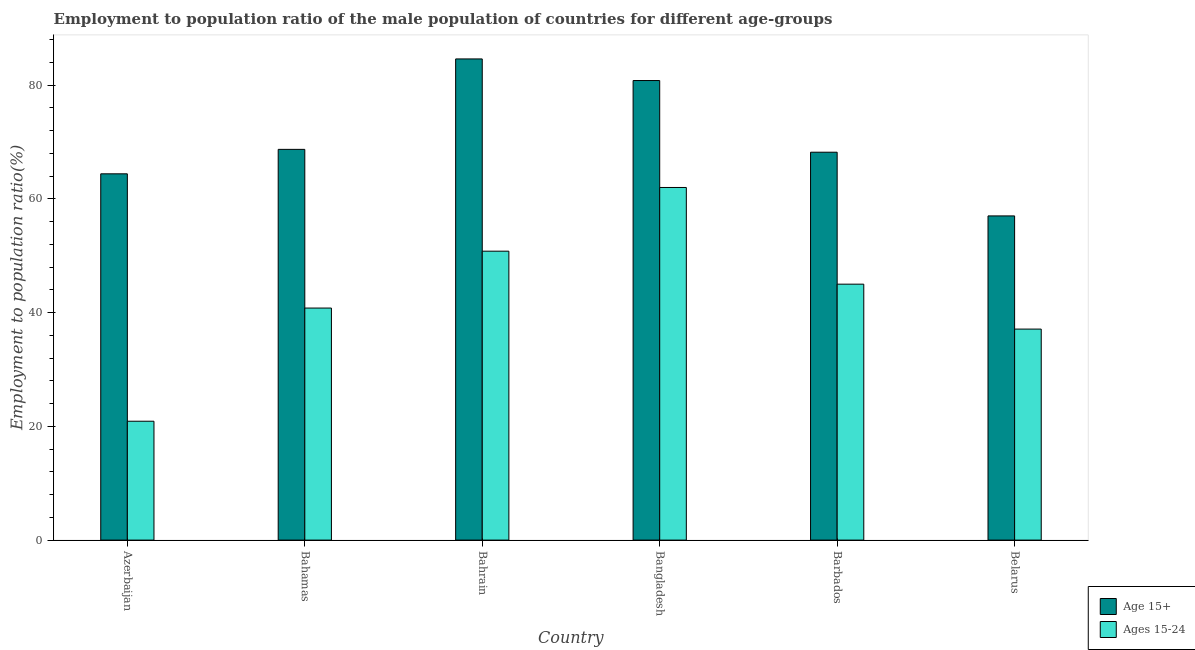What is the label of the 3rd group of bars from the left?
Make the answer very short. Bahrain. What is the employment to population ratio(age 15-24) in Bangladesh?
Give a very brief answer. 62. Across all countries, what is the maximum employment to population ratio(age 15-24)?
Give a very brief answer. 62. Across all countries, what is the minimum employment to population ratio(age 15-24)?
Offer a very short reply. 20.9. In which country was the employment to population ratio(age 15+) maximum?
Your answer should be very brief. Bahrain. In which country was the employment to population ratio(age 15+) minimum?
Provide a succinct answer. Belarus. What is the total employment to population ratio(age 15-24) in the graph?
Your answer should be very brief. 256.6. What is the difference between the employment to population ratio(age 15+) in Bahamas and the employment to population ratio(age 15-24) in Azerbaijan?
Make the answer very short. 47.8. What is the average employment to population ratio(age 15+) per country?
Your answer should be compact. 70.62. What is the difference between the employment to population ratio(age 15-24) and employment to population ratio(age 15+) in Bangladesh?
Offer a terse response. -18.8. In how many countries, is the employment to population ratio(age 15-24) greater than 4 %?
Make the answer very short. 6. What is the ratio of the employment to population ratio(age 15-24) in Bahamas to that in Belarus?
Offer a terse response. 1.1. Is the difference between the employment to population ratio(age 15+) in Bangladesh and Barbados greater than the difference between the employment to population ratio(age 15-24) in Bangladesh and Barbados?
Offer a terse response. No. What is the difference between the highest and the second highest employment to population ratio(age 15-24)?
Give a very brief answer. 11.2. What is the difference between the highest and the lowest employment to population ratio(age 15+)?
Ensure brevity in your answer.  27.6. What does the 1st bar from the left in Bahamas represents?
Ensure brevity in your answer.  Age 15+. What does the 1st bar from the right in Bahrain represents?
Keep it short and to the point. Ages 15-24. How many bars are there?
Make the answer very short. 12. Are all the bars in the graph horizontal?
Your answer should be compact. No. Are the values on the major ticks of Y-axis written in scientific E-notation?
Give a very brief answer. No. Does the graph contain any zero values?
Your response must be concise. No. Does the graph contain grids?
Your response must be concise. No. How many legend labels are there?
Your answer should be very brief. 2. What is the title of the graph?
Your answer should be compact. Employment to population ratio of the male population of countries for different age-groups. Does "Girls" appear as one of the legend labels in the graph?
Give a very brief answer. No. What is the label or title of the X-axis?
Offer a very short reply. Country. What is the Employment to population ratio(%) in Age 15+ in Azerbaijan?
Offer a very short reply. 64.4. What is the Employment to population ratio(%) in Ages 15-24 in Azerbaijan?
Your response must be concise. 20.9. What is the Employment to population ratio(%) in Age 15+ in Bahamas?
Offer a very short reply. 68.7. What is the Employment to population ratio(%) of Ages 15-24 in Bahamas?
Keep it short and to the point. 40.8. What is the Employment to population ratio(%) of Age 15+ in Bahrain?
Offer a very short reply. 84.6. What is the Employment to population ratio(%) in Ages 15-24 in Bahrain?
Keep it short and to the point. 50.8. What is the Employment to population ratio(%) in Age 15+ in Bangladesh?
Provide a short and direct response. 80.8. What is the Employment to population ratio(%) of Ages 15-24 in Bangladesh?
Provide a short and direct response. 62. What is the Employment to population ratio(%) in Age 15+ in Barbados?
Your answer should be very brief. 68.2. What is the Employment to population ratio(%) in Ages 15-24 in Barbados?
Ensure brevity in your answer.  45. What is the Employment to population ratio(%) in Ages 15-24 in Belarus?
Keep it short and to the point. 37.1. Across all countries, what is the maximum Employment to population ratio(%) in Age 15+?
Your response must be concise. 84.6. Across all countries, what is the maximum Employment to population ratio(%) in Ages 15-24?
Your response must be concise. 62. Across all countries, what is the minimum Employment to population ratio(%) in Ages 15-24?
Your answer should be compact. 20.9. What is the total Employment to population ratio(%) of Age 15+ in the graph?
Make the answer very short. 423.7. What is the total Employment to population ratio(%) of Ages 15-24 in the graph?
Offer a terse response. 256.6. What is the difference between the Employment to population ratio(%) in Ages 15-24 in Azerbaijan and that in Bahamas?
Provide a succinct answer. -19.9. What is the difference between the Employment to population ratio(%) in Age 15+ in Azerbaijan and that in Bahrain?
Provide a short and direct response. -20.2. What is the difference between the Employment to population ratio(%) of Ages 15-24 in Azerbaijan and that in Bahrain?
Make the answer very short. -29.9. What is the difference between the Employment to population ratio(%) in Age 15+ in Azerbaijan and that in Bangladesh?
Your answer should be very brief. -16.4. What is the difference between the Employment to population ratio(%) in Ages 15-24 in Azerbaijan and that in Bangladesh?
Your response must be concise. -41.1. What is the difference between the Employment to population ratio(%) of Age 15+ in Azerbaijan and that in Barbados?
Keep it short and to the point. -3.8. What is the difference between the Employment to population ratio(%) of Ages 15-24 in Azerbaijan and that in Barbados?
Provide a succinct answer. -24.1. What is the difference between the Employment to population ratio(%) in Age 15+ in Azerbaijan and that in Belarus?
Provide a succinct answer. 7.4. What is the difference between the Employment to population ratio(%) of Ages 15-24 in Azerbaijan and that in Belarus?
Your answer should be very brief. -16.2. What is the difference between the Employment to population ratio(%) of Age 15+ in Bahamas and that in Bahrain?
Offer a terse response. -15.9. What is the difference between the Employment to population ratio(%) of Age 15+ in Bahamas and that in Bangladesh?
Your answer should be very brief. -12.1. What is the difference between the Employment to population ratio(%) of Ages 15-24 in Bahamas and that in Bangladesh?
Your response must be concise. -21.2. What is the difference between the Employment to population ratio(%) of Age 15+ in Bahamas and that in Barbados?
Keep it short and to the point. 0.5. What is the difference between the Employment to population ratio(%) of Age 15+ in Bahamas and that in Belarus?
Offer a very short reply. 11.7. What is the difference between the Employment to population ratio(%) of Ages 15-24 in Bahamas and that in Belarus?
Keep it short and to the point. 3.7. What is the difference between the Employment to population ratio(%) in Ages 15-24 in Bahrain and that in Barbados?
Provide a succinct answer. 5.8. What is the difference between the Employment to population ratio(%) of Age 15+ in Bahrain and that in Belarus?
Give a very brief answer. 27.6. What is the difference between the Employment to population ratio(%) in Age 15+ in Bangladesh and that in Barbados?
Offer a very short reply. 12.6. What is the difference between the Employment to population ratio(%) in Age 15+ in Bangladesh and that in Belarus?
Your answer should be compact. 23.8. What is the difference between the Employment to population ratio(%) of Ages 15-24 in Bangladesh and that in Belarus?
Your response must be concise. 24.9. What is the difference between the Employment to population ratio(%) in Age 15+ in Barbados and that in Belarus?
Your answer should be compact. 11.2. What is the difference between the Employment to population ratio(%) of Age 15+ in Azerbaijan and the Employment to population ratio(%) of Ages 15-24 in Bahamas?
Ensure brevity in your answer.  23.6. What is the difference between the Employment to population ratio(%) in Age 15+ in Azerbaijan and the Employment to population ratio(%) in Ages 15-24 in Bangladesh?
Provide a succinct answer. 2.4. What is the difference between the Employment to population ratio(%) in Age 15+ in Azerbaijan and the Employment to population ratio(%) in Ages 15-24 in Barbados?
Your response must be concise. 19.4. What is the difference between the Employment to population ratio(%) of Age 15+ in Azerbaijan and the Employment to population ratio(%) of Ages 15-24 in Belarus?
Give a very brief answer. 27.3. What is the difference between the Employment to population ratio(%) of Age 15+ in Bahamas and the Employment to population ratio(%) of Ages 15-24 in Bangladesh?
Offer a very short reply. 6.7. What is the difference between the Employment to population ratio(%) in Age 15+ in Bahamas and the Employment to population ratio(%) in Ages 15-24 in Barbados?
Make the answer very short. 23.7. What is the difference between the Employment to population ratio(%) in Age 15+ in Bahamas and the Employment to population ratio(%) in Ages 15-24 in Belarus?
Provide a succinct answer. 31.6. What is the difference between the Employment to population ratio(%) of Age 15+ in Bahrain and the Employment to population ratio(%) of Ages 15-24 in Bangladesh?
Give a very brief answer. 22.6. What is the difference between the Employment to population ratio(%) of Age 15+ in Bahrain and the Employment to population ratio(%) of Ages 15-24 in Barbados?
Your answer should be compact. 39.6. What is the difference between the Employment to population ratio(%) in Age 15+ in Bahrain and the Employment to population ratio(%) in Ages 15-24 in Belarus?
Keep it short and to the point. 47.5. What is the difference between the Employment to population ratio(%) of Age 15+ in Bangladesh and the Employment to population ratio(%) of Ages 15-24 in Barbados?
Keep it short and to the point. 35.8. What is the difference between the Employment to population ratio(%) in Age 15+ in Bangladesh and the Employment to population ratio(%) in Ages 15-24 in Belarus?
Your answer should be compact. 43.7. What is the difference between the Employment to population ratio(%) in Age 15+ in Barbados and the Employment to population ratio(%) in Ages 15-24 in Belarus?
Your answer should be compact. 31.1. What is the average Employment to population ratio(%) of Age 15+ per country?
Offer a very short reply. 70.62. What is the average Employment to population ratio(%) in Ages 15-24 per country?
Your answer should be compact. 42.77. What is the difference between the Employment to population ratio(%) in Age 15+ and Employment to population ratio(%) in Ages 15-24 in Azerbaijan?
Ensure brevity in your answer.  43.5. What is the difference between the Employment to population ratio(%) of Age 15+ and Employment to population ratio(%) of Ages 15-24 in Bahamas?
Keep it short and to the point. 27.9. What is the difference between the Employment to population ratio(%) in Age 15+ and Employment to population ratio(%) in Ages 15-24 in Bahrain?
Offer a very short reply. 33.8. What is the difference between the Employment to population ratio(%) of Age 15+ and Employment to population ratio(%) of Ages 15-24 in Bangladesh?
Provide a short and direct response. 18.8. What is the difference between the Employment to population ratio(%) of Age 15+ and Employment to population ratio(%) of Ages 15-24 in Barbados?
Your answer should be compact. 23.2. What is the ratio of the Employment to population ratio(%) in Age 15+ in Azerbaijan to that in Bahamas?
Offer a very short reply. 0.94. What is the ratio of the Employment to population ratio(%) in Ages 15-24 in Azerbaijan to that in Bahamas?
Your response must be concise. 0.51. What is the ratio of the Employment to population ratio(%) in Age 15+ in Azerbaijan to that in Bahrain?
Your answer should be very brief. 0.76. What is the ratio of the Employment to population ratio(%) in Ages 15-24 in Azerbaijan to that in Bahrain?
Offer a terse response. 0.41. What is the ratio of the Employment to population ratio(%) of Age 15+ in Azerbaijan to that in Bangladesh?
Provide a succinct answer. 0.8. What is the ratio of the Employment to population ratio(%) of Ages 15-24 in Azerbaijan to that in Bangladesh?
Your answer should be very brief. 0.34. What is the ratio of the Employment to population ratio(%) in Age 15+ in Azerbaijan to that in Barbados?
Offer a very short reply. 0.94. What is the ratio of the Employment to population ratio(%) in Ages 15-24 in Azerbaijan to that in Barbados?
Offer a terse response. 0.46. What is the ratio of the Employment to population ratio(%) of Age 15+ in Azerbaijan to that in Belarus?
Keep it short and to the point. 1.13. What is the ratio of the Employment to population ratio(%) in Ages 15-24 in Azerbaijan to that in Belarus?
Offer a very short reply. 0.56. What is the ratio of the Employment to population ratio(%) in Age 15+ in Bahamas to that in Bahrain?
Keep it short and to the point. 0.81. What is the ratio of the Employment to population ratio(%) in Ages 15-24 in Bahamas to that in Bahrain?
Your response must be concise. 0.8. What is the ratio of the Employment to population ratio(%) of Age 15+ in Bahamas to that in Bangladesh?
Your answer should be very brief. 0.85. What is the ratio of the Employment to population ratio(%) in Ages 15-24 in Bahamas to that in Bangladesh?
Keep it short and to the point. 0.66. What is the ratio of the Employment to population ratio(%) of Age 15+ in Bahamas to that in Barbados?
Make the answer very short. 1.01. What is the ratio of the Employment to population ratio(%) of Ages 15-24 in Bahamas to that in Barbados?
Provide a succinct answer. 0.91. What is the ratio of the Employment to population ratio(%) of Age 15+ in Bahamas to that in Belarus?
Your answer should be very brief. 1.21. What is the ratio of the Employment to population ratio(%) in Ages 15-24 in Bahamas to that in Belarus?
Offer a very short reply. 1.1. What is the ratio of the Employment to population ratio(%) of Age 15+ in Bahrain to that in Bangladesh?
Provide a short and direct response. 1.05. What is the ratio of the Employment to population ratio(%) in Ages 15-24 in Bahrain to that in Bangladesh?
Make the answer very short. 0.82. What is the ratio of the Employment to population ratio(%) of Age 15+ in Bahrain to that in Barbados?
Make the answer very short. 1.24. What is the ratio of the Employment to population ratio(%) in Ages 15-24 in Bahrain to that in Barbados?
Your answer should be very brief. 1.13. What is the ratio of the Employment to population ratio(%) of Age 15+ in Bahrain to that in Belarus?
Offer a terse response. 1.48. What is the ratio of the Employment to population ratio(%) of Ages 15-24 in Bahrain to that in Belarus?
Provide a short and direct response. 1.37. What is the ratio of the Employment to population ratio(%) in Age 15+ in Bangladesh to that in Barbados?
Provide a succinct answer. 1.18. What is the ratio of the Employment to population ratio(%) in Ages 15-24 in Bangladesh to that in Barbados?
Provide a short and direct response. 1.38. What is the ratio of the Employment to population ratio(%) in Age 15+ in Bangladesh to that in Belarus?
Your response must be concise. 1.42. What is the ratio of the Employment to population ratio(%) in Ages 15-24 in Bangladesh to that in Belarus?
Offer a very short reply. 1.67. What is the ratio of the Employment to population ratio(%) in Age 15+ in Barbados to that in Belarus?
Give a very brief answer. 1.2. What is the ratio of the Employment to population ratio(%) in Ages 15-24 in Barbados to that in Belarus?
Offer a very short reply. 1.21. What is the difference between the highest and the second highest Employment to population ratio(%) in Age 15+?
Give a very brief answer. 3.8. What is the difference between the highest and the second highest Employment to population ratio(%) of Ages 15-24?
Offer a very short reply. 11.2. What is the difference between the highest and the lowest Employment to population ratio(%) in Age 15+?
Provide a short and direct response. 27.6. What is the difference between the highest and the lowest Employment to population ratio(%) in Ages 15-24?
Your response must be concise. 41.1. 